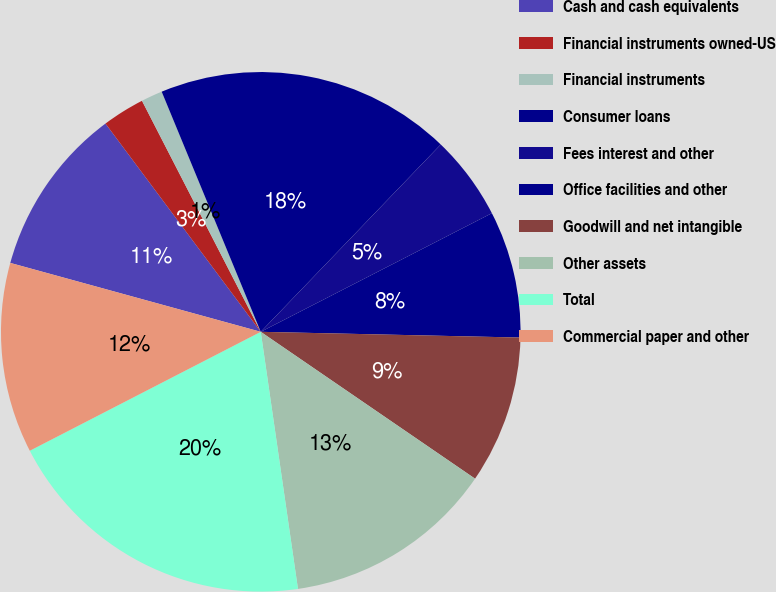Convert chart to OTSL. <chart><loc_0><loc_0><loc_500><loc_500><pie_chart><fcel>Cash and cash equivalents<fcel>Financial instruments owned-US<fcel>Financial instruments<fcel>Consumer loans<fcel>Fees interest and other<fcel>Office facilities and other<fcel>Goodwill and net intangible<fcel>Other assets<fcel>Total<fcel>Commercial paper and other<nl><fcel>10.53%<fcel>2.64%<fcel>1.33%<fcel>18.41%<fcel>5.27%<fcel>7.9%<fcel>9.21%<fcel>13.15%<fcel>19.72%<fcel>11.84%<nl></chart> 